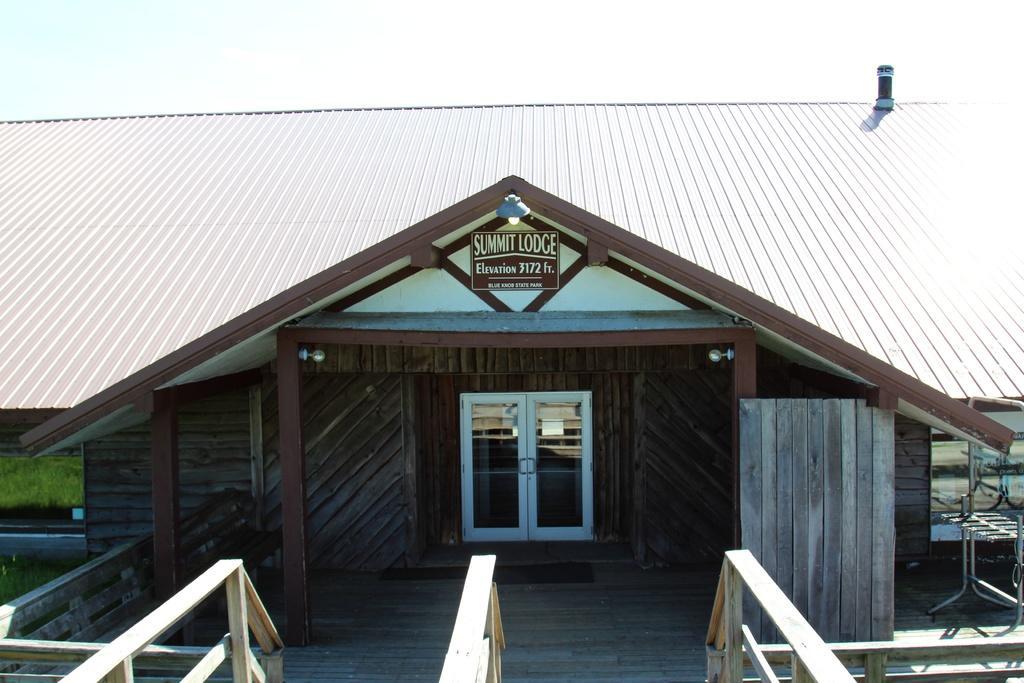Can you describe this image briefly? In this image at front there is a building. Beside the building there is a grass on the surface. At the background there is sky. 